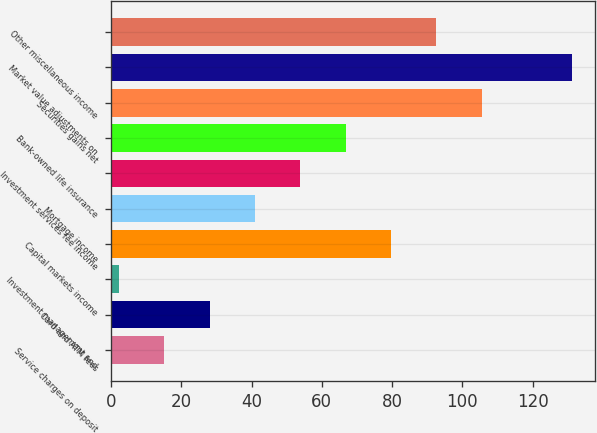Convert chart. <chart><loc_0><loc_0><loc_500><loc_500><bar_chart><fcel>Service charges on deposit<fcel>Card and ATM fees<fcel>Investment management and<fcel>Capital markets income<fcel>Mortgage income<fcel>Investment services fee income<fcel>Bank-owned life insurance<fcel>Securities gains net<fcel>Market value adjustments on<fcel>Other miscellaneous income<nl><fcel>15.11<fcel>28.02<fcel>2.2<fcel>79.66<fcel>40.93<fcel>53.84<fcel>66.75<fcel>105.48<fcel>131.3<fcel>92.57<nl></chart> 